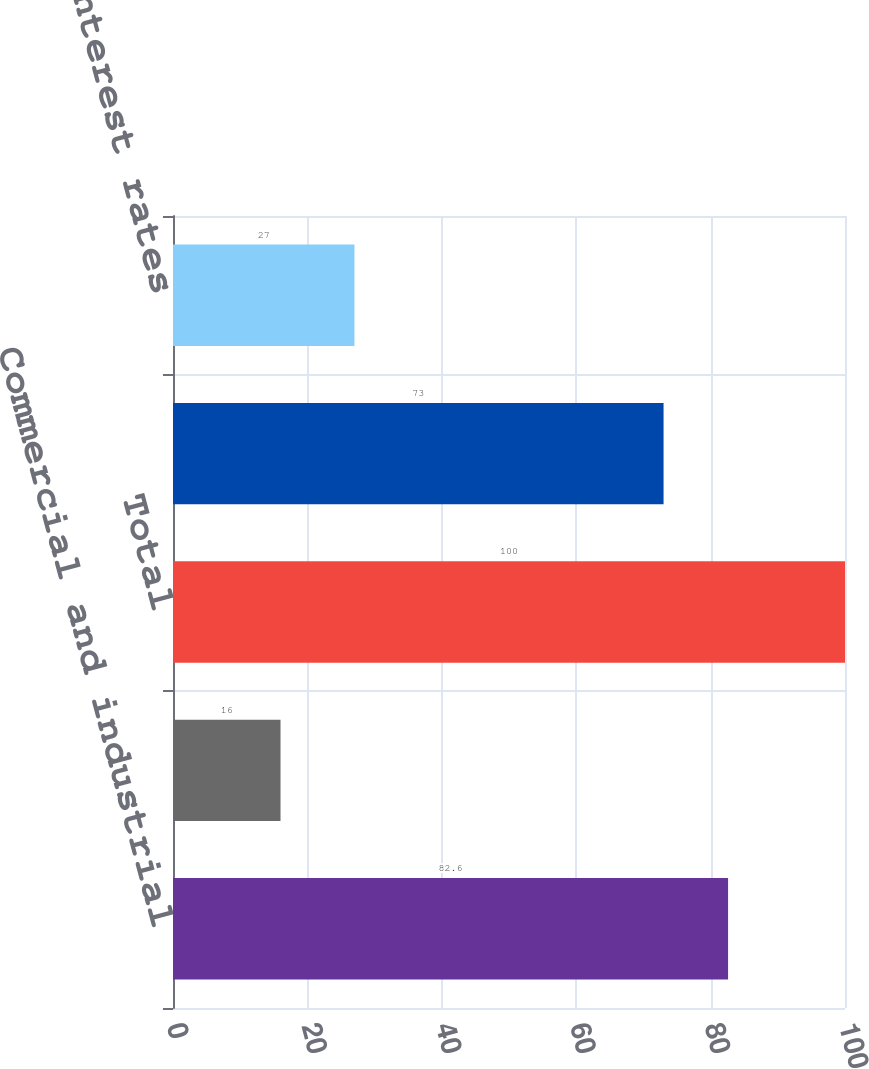Convert chart to OTSL. <chart><loc_0><loc_0><loc_500><loc_500><bar_chart><fcel>Commercial and industrial<fcel>Commercial real<fcel>Total<fcel>Variable-interest rates<fcel>Fixed-interest rates<nl><fcel>82.6<fcel>16<fcel>100<fcel>73<fcel>27<nl></chart> 